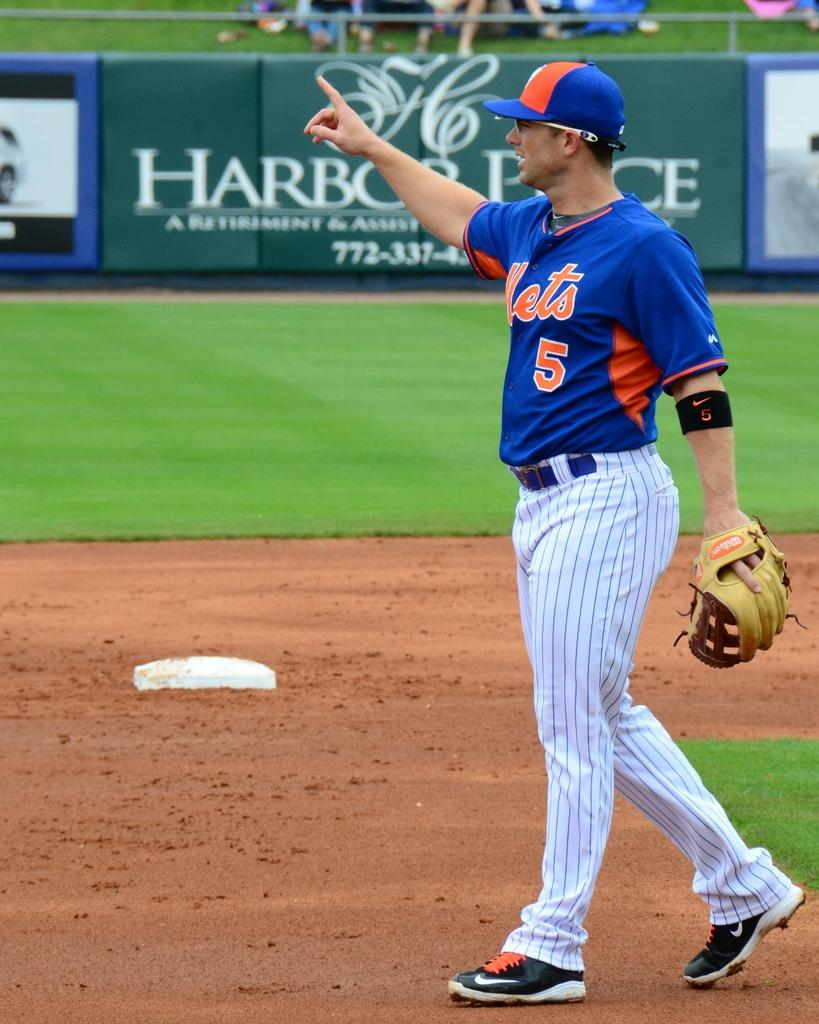<image>
Give a short and clear explanation of the subsequent image. The basebal player wearing jersey no 5 plays for the Mets. 